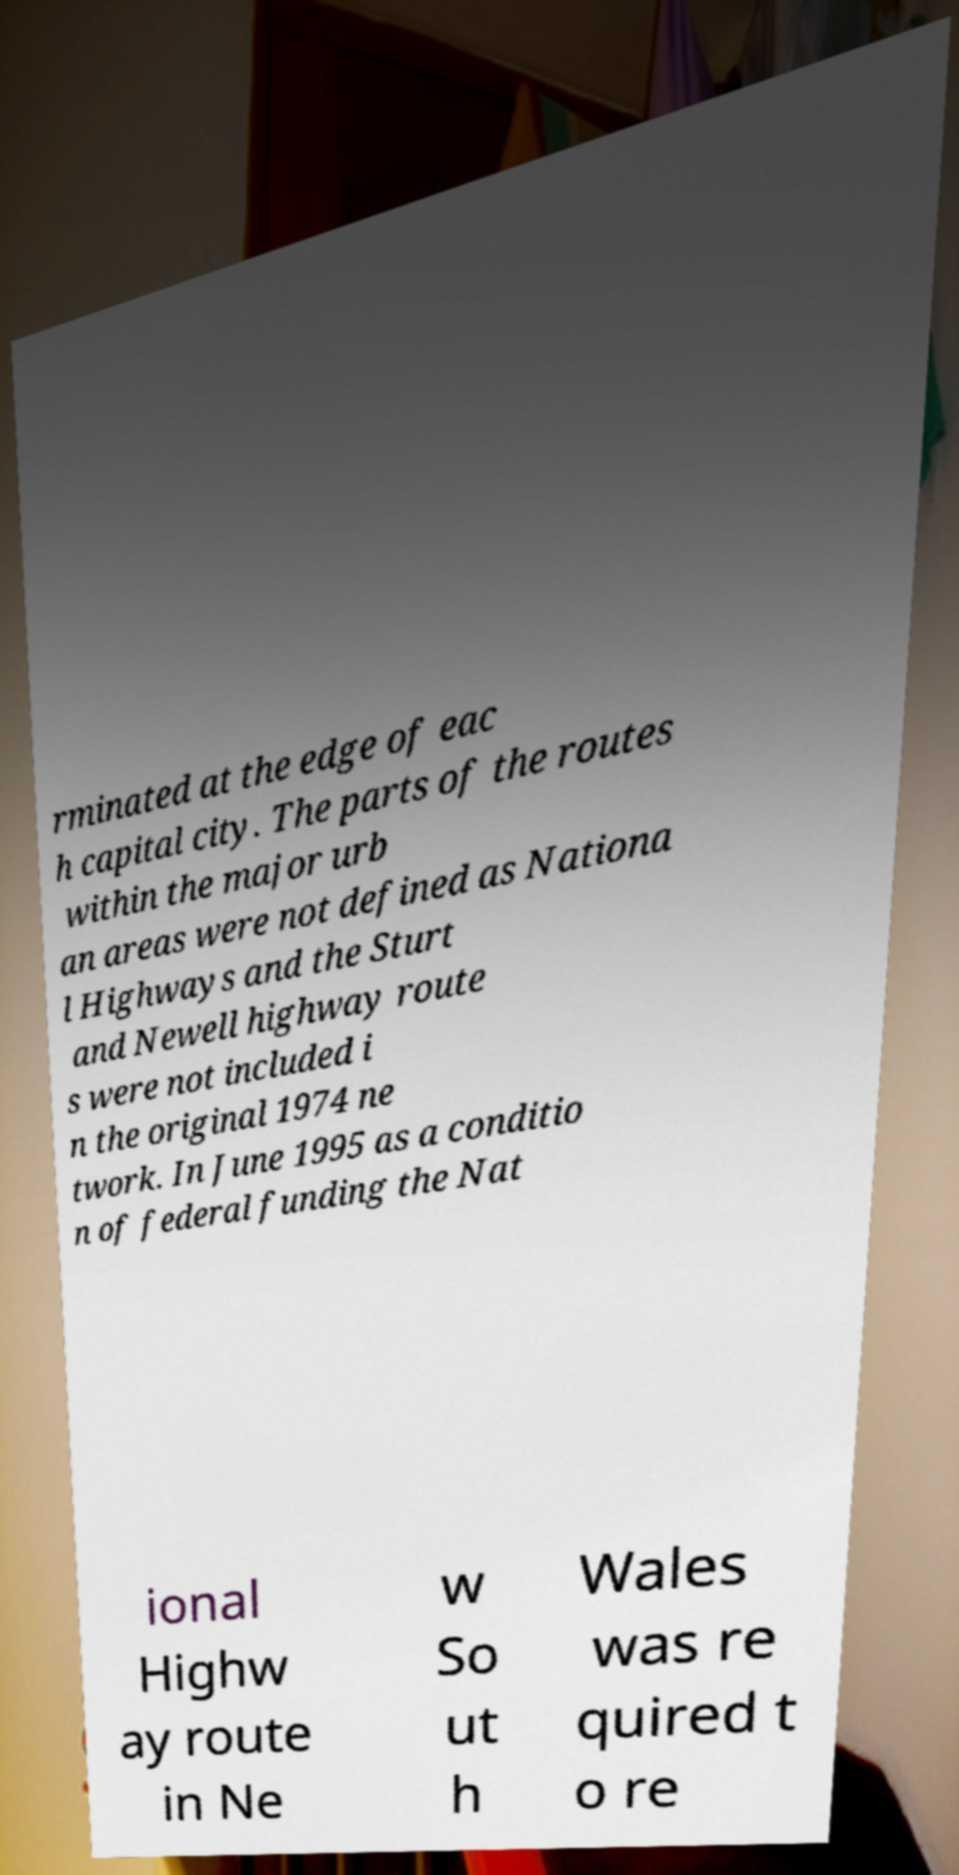Could you extract and type out the text from this image? rminated at the edge of eac h capital city. The parts of the routes within the major urb an areas were not defined as Nationa l Highways and the Sturt and Newell highway route s were not included i n the original 1974 ne twork. In June 1995 as a conditio n of federal funding the Nat ional Highw ay route in Ne w So ut h Wales was re quired t o re 